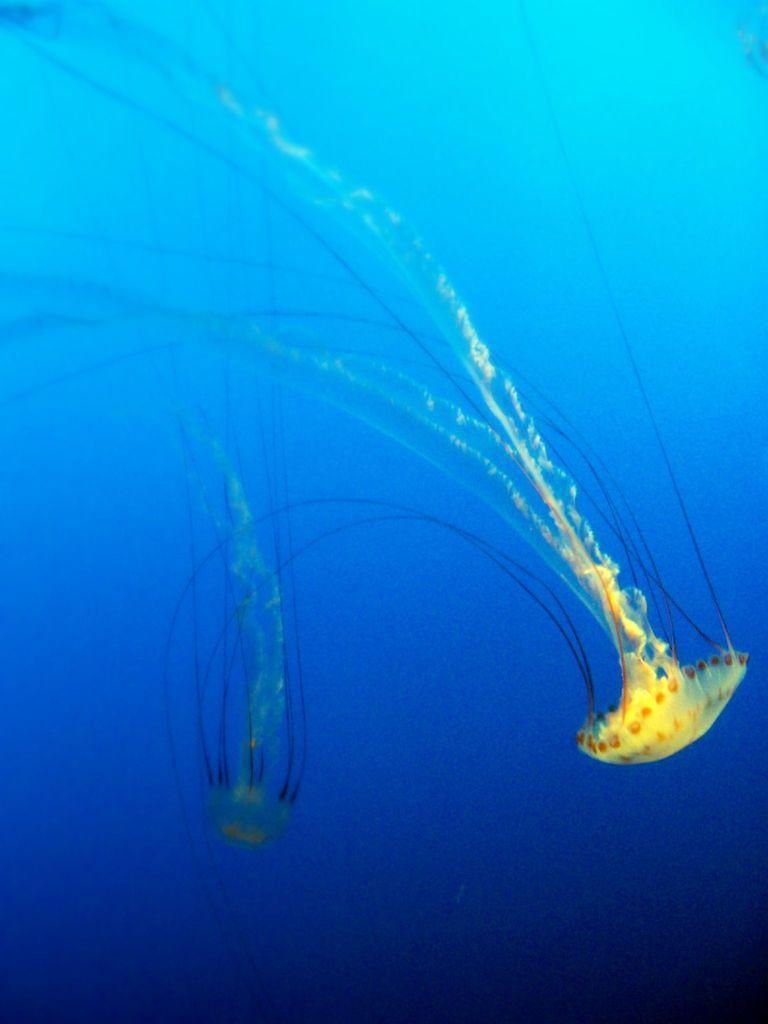Describe this image in one or two sentences. In this image we can see there is a jellyfish in the water. 